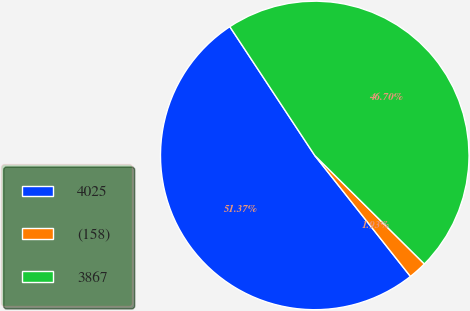<chart> <loc_0><loc_0><loc_500><loc_500><pie_chart><fcel>4025<fcel>(158)<fcel>3867<nl><fcel>51.37%<fcel>1.93%<fcel>46.7%<nl></chart> 